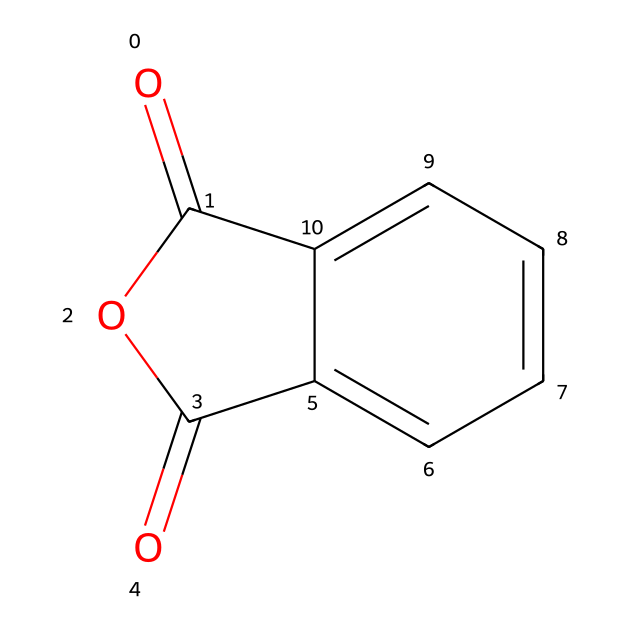What is the molecular formula of phthalic anhydride? The molecular formula is derived from the SMILES representation; carbon (C), hydrogen (H), and oxygen (O) atoms can be counted. There are 8 carbons (C), 4 hydrogens (H), and 3 oxygens (O).
Answer: C8H4O3 How many rings are present in the structure of phthalic anhydride? By analyzing the structure, we see there is one cyclic part indicated by the presence of cyclic carbon atoms. The two carbonyl (C=O) groups contribute to the cyclic nature, forming one ring.
Answer: 1 What type of functional groups are present in phthalic anhydride? The structure includes anhydride functional groups, identified by the carbonyl (C=O) adjacent to an oxygen atom in a cyclic structure.
Answer: anhydride How many double bonds are present in phthalic anhydride? Count the double bonds from the carbonyl groups (C=O) and observe in the structure. There are two carbonyl double bonds in the compound.
Answer: 2 What is the total number of carbon atoms in phthalic anhydride? The structure indicates that there are a total of 8 carbon atoms, which can be confirmed by counting each carbon in the cyclic and acyclic parts of the structure.
Answer: 8 Is phthalic anhydride a solid or a liquid at room temperature? Based on the known properties of phthalic anhydride, it is typically found in solid form at room temperature.
Answer: solid 